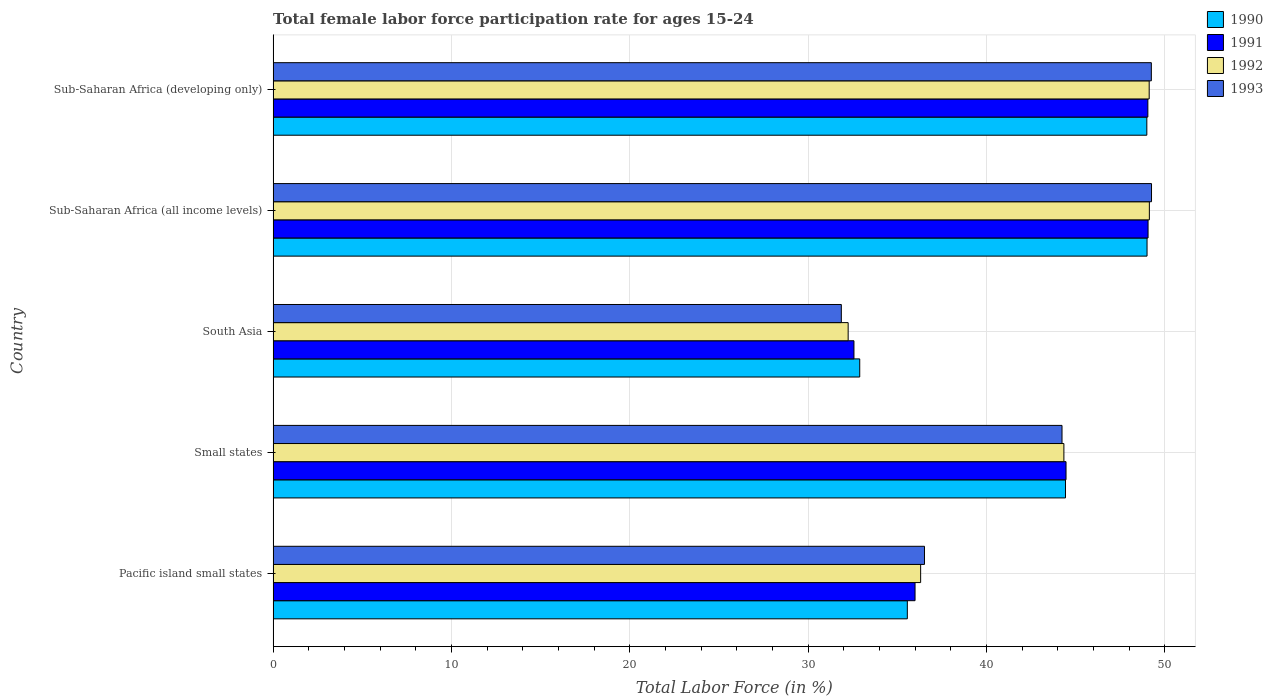How many groups of bars are there?
Offer a terse response. 5. Are the number of bars per tick equal to the number of legend labels?
Your response must be concise. Yes. How many bars are there on the 2nd tick from the top?
Your answer should be compact. 4. What is the label of the 5th group of bars from the top?
Provide a short and direct response. Pacific island small states. What is the female labor force participation rate in 1993 in Small states?
Offer a very short reply. 44.24. Across all countries, what is the maximum female labor force participation rate in 1990?
Make the answer very short. 49. Across all countries, what is the minimum female labor force participation rate in 1993?
Give a very brief answer. 31.86. In which country was the female labor force participation rate in 1991 maximum?
Provide a succinct answer. Sub-Saharan Africa (all income levels). In which country was the female labor force participation rate in 1992 minimum?
Your response must be concise. South Asia. What is the total female labor force participation rate in 1992 in the graph?
Offer a terse response. 211.15. What is the difference between the female labor force participation rate in 1992 in Small states and that in Sub-Saharan Africa (developing only)?
Your answer should be compact. -4.78. What is the difference between the female labor force participation rate in 1993 in South Asia and the female labor force participation rate in 1991 in Sub-Saharan Africa (developing only)?
Your response must be concise. -17.19. What is the average female labor force participation rate in 1991 per country?
Offer a terse response. 42.23. What is the difference between the female labor force participation rate in 1993 and female labor force participation rate in 1992 in Sub-Saharan Africa (all income levels)?
Provide a succinct answer. 0.12. In how many countries, is the female labor force participation rate in 1991 greater than 30 %?
Keep it short and to the point. 5. What is the ratio of the female labor force participation rate in 1991 in Sub-Saharan Africa (all income levels) to that in Sub-Saharan Africa (developing only)?
Offer a terse response. 1. Is the difference between the female labor force participation rate in 1993 in Small states and Sub-Saharan Africa (developing only) greater than the difference between the female labor force participation rate in 1992 in Small states and Sub-Saharan Africa (developing only)?
Your response must be concise. No. What is the difference between the highest and the second highest female labor force participation rate in 1991?
Your answer should be very brief. 0.01. What is the difference between the highest and the lowest female labor force participation rate in 1991?
Provide a short and direct response. 16.49. What does the 3rd bar from the bottom in Sub-Saharan Africa (developing only) represents?
Keep it short and to the point. 1992. How many bars are there?
Make the answer very short. 20. How many countries are there in the graph?
Provide a short and direct response. 5. What is the difference between two consecutive major ticks on the X-axis?
Offer a terse response. 10. Are the values on the major ticks of X-axis written in scientific E-notation?
Ensure brevity in your answer.  No. Does the graph contain any zero values?
Give a very brief answer. No. Does the graph contain grids?
Provide a succinct answer. Yes. How many legend labels are there?
Your answer should be very brief. 4. What is the title of the graph?
Keep it short and to the point. Total female labor force participation rate for ages 15-24. Does "1965" appear as one of the legend labels in the graph?
Give a very brief answer. No. What is the label or title of the X-axis?
Ensure brevity in your answer.  Total Labor Force (in %). What is the Total Labor Force (in %) of 1990 in Pacific island small states?
Your response must be concise. 35.56. What is the Total Labor Force (in %) of 1991 in Pacific island small states?
Ensure brevity in your answer.  35.99. What is the Total Labor Force (in %) in 1992 in Pacific island small states?
Provide a succinct answer. 36.31. What is the Total Labor Force (in %) of 1993 in Pacific island small states?
Provide a short and direct response. 36.52. What is the Total Labor Force (in %) of 1990 in Small states?
Provide a succinct answer. 44.43. What is the Total Labor Force (in %) in 1991 in Small states?
Your response must be concise. 44.46. What is the Total Labor Force (in %) of 1992 in Small states?
Keep it short and to the point. 44.34. What is the Total Labor Force (in %) in 1993 in Small states?
Make the answer very short. 44.24. What is the Total Labor Force (in %) in 1990 in South Asia?
Provide a short and direct response. 32.89. What is the Total Labor Force (in %) in 1991 in South Asia?
Provide a succinct answer. 32.57. What is the Total Labor Force (in %) of 1992 in South Asia?
Your answer should be compact. 32.24. What is the Total Labor Force (in %) of 1993 in South Asia?
Your answer should be very brief. 31.86. What is the Total Labor Force (in %) in 1990 in Sub-Saharan Africa (all income levels)?
Ensure brevity in your answer.  49. What is the Total Labor Force (in %) of 1991 in Sub-Saharan Africa (all income levels)?
Your answer should be very brief. 49.06. What is the Total Labor Force (in %) in 1992 in Sub-Saharan Africa (all income levels)?
Your response must be concise. 49.13. What is the Total Labor Force (in %) of 1993 in Sub-Saharan Africa (all income levels)?
Your answer should be compact. 49.25. What is the Total Labor Force (in %) in 1990 in Sub-Saharan Africa (developing only)?
Make the answer very short. 48.99. What is the Total Labor Force (in %) of 1991 in Sub-Saharan Africa (developing only)?
Your answer should be compact. 49.05. What is the Total Labor Force (in %) in 1992 in Sub-Saharan Africa (developing only)?
Ensure brevity in your answer.  49.12. What is the Total Labor Force (in %) in 1993 in Sub-Saharan Africa (developing only)?
Your answer should be very brief. 49.24. Across all countries, what is the maximum Total Labor Force (in %) in 1990?
Offer a very short reply. 49. Across all countries, what is the maximum Total Labor Force (in %) of 1991?
Provide a short and direct response. 49.06. Across all countries, what is the maximum Total Labor Force (in %) of 1992?
Your answer should be compact. 49.13. Across all countries, what is the maximum Total Labor Force (in %) in 1993?
Your answer should be compact. 49.25. Across all countries, what is the minimum Total Labor Force (in %) in 1990?
Offer a very short reply. 32.89. Across all countries, what is the minimum Total Labor Force (in %) of 1991?
Your answer should be very brief. 32.57. Across all countries, what is the minimum Total Labor Force (in %) in 1992?
Provide a short and direct response. 32.24. Across all countries, what is the minimum Total Labor Force (in %) of 1993?
Make the answer very short. 31.86. What is the total Total Labor Force (in %) of 1990 in the graph?
Give a very brief answer. 210.88. What is the total Total Labor Force (in %) in 1991 in the graph?
Keep it short and to the point. 211.13. What is the total Total Labor Force (in %) in 1992 in the graph?
Provide a short and direct response. 211.15. What is the total Total Labor Force (in %) in 1993 in the graph?
Your response must be concise. 211.12. What is the difference between the Total Labor Force (in %) in 1990 in Pacific island small states and that in Small states?
Offer a very short reply. -8.87. What is the difference between the Total Labor Force (in %) in 1991 in Pacific island small states and that in Small states?
Provide a succinct answer. -8.47. What is the difference between the Total Labor Force (in %) of 1992 in Pacific island small states and that in Small states?
Keep it short and to the point. -8.03. What is the difference between the Total Labor Force (in %) in 1993 in Pacific island small states and that in Small states?
Your answer should be very brief. -7.71. What is the difference between the Total Labor Force (in %) of 1990 in Pacific island small states and that in South Asia?
Your answer should be very brief. 2.67. What is the difference between the Total Labor Force (in %) in 1991 in Pacific island small states and that in South Asia?
Provide a succinct answer. 3.43. What is the difference between the Total Labor Force (in %) of 1992 in Pacific island small states and that in South Asia?
Give a very brief answer. 4.06. What is the difference between the Total Labor Force (in %) of 1993 in Pacific island small states and that in South Asia?
Offer a terse response. 4.66. What is the difference between the Total Labor Force (in %) of 1990 in Pacific island small states and that in Sub-Saharan Africa (all income levels)?
Your response must be concise. -13.44. What is the difference between the Total Labor Force (in %) in 1991 in Pacific island small states and that in Sub-Saharan Africa (all income levels)?
Offer a terse response. -13.07. What is the difference between the Total Labor Force (in %) in 1992 in Pacific island small states and that in Sub-Saharan Africa (all income levels)?
Ensure brevity in your answer.  -12.82. What is the difference between the Total Labor Force (in %) in 1993 in Pacific island small states and that in Sub-Saharan Africa (all income levels)?
Provide a short and direct response. -12.73. What is the difference between the Total Labor Force (in %) in 1990 in Pacific island small states and that in Sub-Saharan Africa (developing only)?
Your answer should be compact. -13.43. What is the difference between the Total Labor Force (in %) of 1991 in Pacific island small states and that in Sub-Saharan Africa (developing only)?
Your answer should be very brief. -13.05. What is the difference between the Total Labor Force (in %) in 1992 in Pacific island small states and that in Sub-Saharan Africa (developing only)?
Give a very brief answer. -12.81. What is the difference between the Total Labor Force (in %) in 1993 in Pacific island small states and that in Sub-Saharan Africa (developing only)?
Your response must be concise. -12.72. What is the difference between the Total Labor Force (in %) of 1990 in Small states and that in South Asia?
Make the answer very short. 11.54. What is the difference between the Total Labor Force (in %) in 1991 in Small states and that in South Asia?
Offer a terse response. 11.89. What is the difference between the Total Labor Force (in %) of 1992 in Small states and that in South Asia?
Give a very brief answer. 12.1. What is the difference between the Total Labor Force (in %) in 1993 in Small states and that in South Asia?
Your response must be concise. 12.37. What is the difference between the Total Labor Force (in %) in 1990 in Small states and that in Sub-Saharan Africa (all income levels)?
Offer a terse response. -4.57. What is the difference between the Total Labor Force (in %) in 1991 in Small states and that in Sub-Saharan Africa (all income levels)?
Give a very brief answer. -4.6. What is the difference between the Total Labor Force (in %) of 1992 in Small states and that in Sub-Saharan Africa (all income levels)?
Your answer should be compact. -4.79. What is the difference between the Total Labor Force (in %) in 1993 in Small states and that in Sub-Saharan Africa (all income levels)?
Your response must be concise. -5.02. What is the difference between the Total Labor Force (in %) in 1990 in Small states and that in Sub-Saharan Africa (developing only)?
Keep it short and to the point. -4.56. What is the difference between the Total Labor Force (in %) of 1991 in Small states and that in Sub-Saharan Africa (developing only)?
Keep it short and to the point. -4.59. What is the difference between the Total Labor Force (in %) in 1992 in Small states and that in Sub-Saharan Africa (developing only)?
Make the answer very short. -4.78. What is the difference between the Total Labor Force (in %) of 1993 in Small states and that in Sub-Saharan Africa (developing only)?
Make the answer very short. -5.01. What is the difference between the Total Labor Force (in %) of 1990 in South Asia and that in Sub-Saharan Africa (all income levels)?
Offer a terse response. -16.11. What is the difference between the Total Labor Force (in %) of 1991 in South Asia and that in Sub-Saharan Africa (all income levels)?
Offer a very short reply. -16.49. What is the difference between the Total Labor Force (in %) of 1992 in South Asia and that in Sub-Saharan Africa (all income levels)?
Make the answer very short. -16.89. What is the difference between the Total Labor Force (in %) in 1993 in South Asia and that in Sub-Saharan Africa (all income levels)?
Keep it short and to the point. -17.39. What is the difference between the Total Labor Force (in %) in 1990 in South Asia and that in Sub-Saharan Africa (developing only)?
Offer a terse response. -16.1. What is the difference between the Total Labor Force (in %) in 1991 in South Asia and that in Sub-Saharan Africa (developing only)?
Ensure brevity in your answer.  -16.48. What is the difference between the Total Labor Force (in %) in 1992 in South Asia and that in Sub-Saharan Africa (developing only)?
Give a very brief answer. -16.88. What is the difference between the Total Labor Force (in %) in 1993 in South Asia and that in Sub-Saharan Africa (developing only)?
Ensure brevity in your answer.  -17.38. What is the difference between the Total Labor Force (in %) in 1990 in Sub-Saharan Africa (all income levels) and that in Sub-Saharan Africa (developing only)?
Provide a succinct answer. 0.01. What is the difference between the Total Labor Force (in %) of 1991 in Sub-Saharan Africa (all income levels) and that in Sub-Saharan Africa (developing only)?
Keep it short and to the point. 0.01. What is the difference between the Total Labor Force (in %) in 1992 in Sub-Saharan Africa (all income levels) and that in Sub-Saharan Africa (developing only)?
Your response must be concise. 0.01. What is the difference between the Total Labor Force (in %) in 1993 in Sub-Saharan Africa (all income levels) and that in Sub-Saharan Africa (developing only)?
Provide a succinct answer. 0.01. What is the difference between the Total Labor Force (in %) of 1990 in Pacific island small states and the Total Labor Force (in %) of 1991 in Small states?
Your answer should be compact. -8.9. What is the difference between the Total Labor Force (in %) of 1990 in Pacific island small states and the Total Labor Force (in %) of 1992 in Small states?
Your answer should be compact. -8.78. What is the difference between the Total Labor Force (in %) of 1990 in Pacific island small states and the Total Labor Force (in %) of 1993 in Small states?
Give a very brief answer. -8.67. What is the difference between the Total Labor Force (in %) in 1991 in Pacific island small states and the Total Labor Force (in %) in 1992 in Small states?
Ensure brevity in your answer.  -8.35. What is the difference between the Total Labor Force (in %) of 1991 in Pacific island small states and the Total Labor Force (in %) of 1993 in Small states?
Make the answer very short. -8.24. What is the difference between the Total Labor Force (in %) in 1992 in Pacific island small states and the Total Labor Force (in %) in 1993 in Small states?
Provide a succinct answer. -7.93. What is the difference between the Total Labor Force (in %) in 1990 in Pacific island small states and the Total Labor Force (in %) in 1991 in South Asia?
Give a very brief answer. 2.99. What is the difference between the Total Labor Force (in %) of 1990 in Pacific island small states and the Total Labor Force (in %) of 1992 in South Asia?
Keep it short and to the point. 3.32. What is the difference between the Total Labor Force (in %) of 1990 in Pacific island small states and the Total Labor Force (in %) of 1993 in South Asia?
Ensure brevity in your answer.  3.7. What is the difference between the Total Labor Force (in %) of 1991 in Pacific island small states and the Total Labor Force (in %) of 1992 in South Asia?
Your response must be concise. 3.75. What is the difference between the Total Labor Force (in %) in 1991 in Pacific island small states and the Total Labor Force (in %) in 1993 in South Asia?
Provide a succinct answer. 4.13. What is the difference between the Total Labor Force (in %) in 1992 in Pacific island small states and the Total Labor Force (in %) in 1993 in South Asia?
Provide a short and direct response. 4.45. What is the difference between the Total Labor Force (in %) of 1990 in Pacific island small states and the Total Labor Force (in %) of 1991 in Sub-Saharan Africa (all income levels)?
Provide a short and direct response. -13.5. What is the difference between the Total Labor Force (in %) of 1990 in Pacific island small states and the Total Labor Force (in %) of 1992 in Sub-Saharan Africa (all income levels)?
Keep it short and to the point. -13.57. What is the difference between the Total Labor Force (in %) of 1990 in Pacific island small states and the Total Labor Force (in %) of 1993 in Sub-Saharan Africa (all income levels)?
Your response must be concise. -13.69. What is the difference between the Total Labor Force (in %) of 1991 in Pacific island small states and the Total Labor Force (in %) of 1992 in Sub-Saharan Africa (all income levels)?
Your answer should be compact. -13.14. What is the difference between the Total Labor Force (in %) of 1991 in Pacific island small states and the Total Labor Force (in %) of 1993 in Sub-Saharan Africa (all income levels)?
Provide a short and direct response. -13.26. What is the difference between the Total Labor Force (in %) in 1992 in Pacific island small states and the Total Labor Force (in %) in 1993 in Sub-Saharan Africa (all income levels)?
Keep it short and to the point. -12.95. What is the difference between the Total Labor Force (in %) of 1990 in Pacific island small states and the Total Labor Force (in %) of 1991 in Sub-Saharan Africa (developing only)?
Your answer should be very brief. -13.49. What is the difference between the Total Labor Force (in %) in 1990 in Pacific island small states and the Total Labor Force (in %) in 1992 in Sub-Saharan Africa (developing only)?
Provide a short and direct response. -13.56. What is the difference between the Total Labor Force (in %) of 1990 in Pacific island small states and the Total Labor Force (in %) of 1993 in Sub-Saharan Africa (developing only)?
Provide a short and direct response. -13.68. What is the difference between the Total Labor Force (in %) in 1991 in Pacific island small states and the Total Labor Force (in %) in 1992 in Sub-Saharan Africa (developing only)?
Offer a very short reply. -13.13. What is the difference between the Total Labor Force (in %) of 1991 in Pacific island small states and the Total Labor Force (in %) of 1993 in Sub-Saharan Africa (developing only)?
Your response must be concise. -13.25. What is the difference between the Total Labor Force (in %) in 1992 in Pacific island small states and the Total Labor Force (in %) in 1993 in Sub-Saharan Africa (developing only)?
Ensure brevity in your answer.  -12.94. What is the difference between the Total Labor Force (in %) of 1990 in Small states and the Total Labor Force (in %) of 1991 in South Asia?
Give a very brief answer. 11.86. What is the difference between the Total Labor Force (in %) in 1990 in Small states and the Total Labor Force (in %) in 1992 in South Asia?
Give a very brief answer. 12.19. What is the difference between the Total Labor Force (in %) of 1990 in Small states and the Total Labor Force (in %) of 1993 in South Asia?
Offer a very short reply. 12.57. What is the difference between the Total Labor Force (in %) in 1991 in Small states and the Total Labor Force (in %) in 1992 in South Asia?
Your answer should be very brief. 12.22. What is the difference between the Total Labor Force (in %) in 1991 in Small states and the Total Labor Force (in %) in 1993 in South Asia?
Provide a short and direct response. 12.6. What is the difference between the Total Labor Force (in %) in 1992 in Small states and the Total Labor Force (in %) in 1993 in South Asia?
Offer a terse response. 12.48. What is the difference between the Total Labor Force (in %) of 1990 in Small states and the Total Labor Force (in %) of 1991 in Sub-Saharan Africa (all income levels)?
Provide a succinct answer. -4.63. What is the difference between the Total Labor Force (in %) of 1990 in Small states and the Total Labor Force (in %) of 1992 in Sub-Saharan Africa (all income levels)?
Offer a very short reply. -4.7. What is the difference between the Total Labor Force (in %) of 1990 in Small states and the Total Labor Force (in %) of 1993 in Sub-Saharan Africa (all income levels)?
Your answer should be compact. -4.82. What is the difference between the Total Labor Force (in %) in 1991 in Small states and the Total Labor Force (in %) in 1992 in Sub-Saharan Africa (all income levels)?
Keep it short and to the point. -4.67. What is the difference between the Total Labor Force (in %) of 1991 in Small states and the Total Labor Force (in %) of 1993 in Sub-Saharan Africa (all income levels)?
Your answer should be compact. -4.79. What is the difference between the Total Labor Force (in %) of 1992 in Small states and the Total Labor Force (in %) of 1993 in Sub-Saharan Africa (all income levels)?
Provide a succinct answer. -4.91. What is the difference between the Total Labor Force (in %) of 1990 in Small states and the Total Labor Force (in %) of 1991 in Sub-Saharan Africa (developing only)?
Offer a terse response. -4.62. What is the difference between the Total Labor Force (in %) in 1990 in Small states and the Total Labor Force (in %) in 1992 in Sub-Saharan Africa (developing only)?
Your answer should be very brief. -4.69. What is the difference between the Total Labor Force (in %) in 1990 in Small states and the Total Labor Force (in %) in 1993 in Sub-Saharan Africa (developing only)?
Provide a succinct answer. -4.81. What is the difference between the Total Labor Force (in %) of 1991 in Small states and the Total Labor Force (in %) of 1992 in Sub-Saharan Africa (developing only)?
Provide a succinct answer. -4.66. What is the difference between the Total Labor Force (in %) of 1991 in Small states and the Total Labor Force (in %) of 1993 in Sub-Saharan Africa (developing only)?
Offer a very short reply. -4.78. What is the difference between the Total Labor Force (in %) of 1992 in Small states and the Total Labor Force (in %) of 1993 in Sub-Saharan Africa (developing only)?
Keep it short and to the point. -4.9. What is the difference between the Total Labor Force (in %) of 1990 in South Asia and the Total Labor Force (in %) of 1991 in Sub-Saharan Africa (all income levels)?
Your answer should be very brief. -16.17. What is the difference between the Total Labor Force (in %) in 1990 in South Asia and the Total Labor Force (in %) in 1992 in Sub-Saharan Africa (all income levels)?
Keep it short and to the point. -16.24. What is the difference between the Total Labor Force (in %) in 1990 in South Asia and the Total Labor Force (in %) in 1993 in Sub-Saharan Africa (all income levels)?
Offer a terse response. -16.36. What is the difference between the Total Labor Force (in %) of 1991 in South Asia and the Total Labor Force (in %) of 1992 in Sub-Saharan Africa (all income levels)?
Offer a terse response. -16.56. What is the difference between the Total Labor Force (in %) of 1991 in South Asia and the Total Labor Force (in %) of 1993 in Sub-Saharan Africa (all income levels)?
Offer a very short reply. -16.68. What is the difference between the Total Labor Force (in %) of 1992 in South Asia and the Total Labor Force (in %) of 1993 in Sub-Saharan Africa (all income levels)?
Offer a very short reply. -17.01. What is the difference between the Total Labor Force (in %) in 1990 in South Asia and the Total Labor Force (in %) in 1991 in Sub-Saharan Africa (developing only)?
Keep it short and to the point. -16.16. What is the difference between the Total Labor Force (in %) in 1990 in South Asia and the Total Labor Force (in %) in 1992 in Sub-Saharan Africa (developing only)?
Keep it short and to the point. -16.23. What is the difference between the Total Labor Force (in %) of 1990 in South Asia and the Total Labor Force (in %) of 1993 in Sub-Saharan Africa (developing only)?
Provide a succinct answer. -16.35. What is the difference between the Total Labor Force (in %) of 1991 in South Asia and the Total Labor Force (in %) of 1992 in Sub-Saharan Africa (developing only)?
Offer a very short reply. -16.55. What is the difference between the Total Labor Force (in %) of 1991 in South Asia and the Total Labor Force (in %) of 1993 in Sub-Saharan Africa (developing only)?
Your answer should be compact. -16.68. What is the difference between the Total Labor Force (in %) of 1992 in South Asia and the Total Labor Force (in %) of 1993 in Sub-Saharan Africa (developing only)?
Ensure brevity in your answer.  -17. What is the difference between the Total Labor Force (in %) of 1990 in Sub-Saharan Africa (all income levels) and the Total Labor Force (in %) of 1991 in Sub-Saharan Africa (developing only)?
Provide a short and direct response. -0.05. What is the difference between the Total Labor Force (in %) of 1990 in Sub-Saharan Africa (all income levels) and the Total Labor Force (in %) of 1992 in Sub-Saharan Africa (developing only)?
Your response must be concise. -0.12. What is the difference between the Total Labor Force (in %) in 1990 in Sub-Saharan Africa (all income levels) and the Total Labor Force (in %) in 1993 in Sub-Saharan Africa (developing only)?
Give a very brief answer. -0.24. What is the difference between the Total Labor Force (in %) in 1991 in Sub-Saharan Africa (all income levels) and the Total Labor Force (in %) in 1992 in Sub-Saharan Africa (developing only)?
Your response must be concise. -0.06. What is the difference between the Total Labor Force (in %) of 1991 in Sub-Saharan Africa (all income levels) and the Total Labor Force (in %) of 1993 in Sub-Saharan Africa (developing only)?
Offer a terse response. -0.18. What is the difference between the Total Labor Force (in %) in 1992 in Sub-Saharan Africa (all income levels) and the Total Labor Force (in %) in 1993 in Sub-Saharan Africa (developing only)?
Ensure brevity in your answer.  -0.11. What is the average Total Labor Force (in %) of 1990 per country?
Provide a succinct answer. 42.18. What is the average Total Labor Force (in %) in 1991 per country?
Provide a succinct answer. 42.23. What is the average Total Labor Force (in %) of 1992 per country?
Provide a short and direct response. 42.23. What is the average Total Labor Force (in %) in 1993 per country?
Provide a succinct answer. 42.22. What is the difference between the Total Labor Force (in %) in 1990 and Total Labor Force (in %) in 1991 in Pacific island small states?
Offer a very short reply. -0.43. What is the difference between the Total Labor Force (in %) of 1990 and Total Labor Force (in %) of 1992 in Pacific island small states?
Provide a succinct answer. -0.75. What is the difference between the Total Labor Force (in %) of 1990 and Total Labor Force (in %) of 1993 in Pacific island small states?
Your response must be concise. -0.96. What is the difference between the Total Labor Force (in %) of 1991 and Total Labor Force (in %) of 1992 in Pacific island small states?
Your answer should be compact. -0.31. What is the difference between the Total Labor Force (in %) of 1991 and Total Labor Force (in %) of 1993 in Pacific island small states?
Make the answer very short. -0.53. What is the difference between the Total Labor Force (in %) of 1992 and Total Labor Force (in %) of 1993 in Pacific island small states?
Offer a very short reply. -0.22. What is the difference between the Total Labor Force (in %) in 1990 and Total Labor Force (in %) in 1991 in Small states?
Make the answer very short. -0.03. What is the difference between the Total Labor Force (in %) in 1990 and Total Labor Force (in %) in 1992 in Small states?
Your answer should be very brief. 0.09. What is the difference between the Total Labor Force (in %) in 1990 and Total Labor Force (in %) in 1993 in Small states?
Give a very brief answer. 0.19. What is the difference between the Total Labor Force (in %) in 1991 and Total Labor Force (in %) in 1992 in Small states?
Offer a terse response. 0.12. What is the difference between the Total Labor Force (in %) in 1991 and Total Labor Force (in %) in 1993 in Small states?
Your answer should be very brief. 0.22. What is the difference between the Total Labor Force (in %) of 1992 and Total Labor Force (in %) of 1993 in Small states?
Provide a short and direct response. 0.1. What is the difference between the Total Labor Force (in %) of 1990 and Total Labor Force (in %) of 1991 in South Asia?
Give a very brief answer. 0.32. What is the difference between the Total Labor Force (in %) in 1990 and Total Labor Force (in %) in 1992 in South Asia?
Offer a terse response. 0.65. What is the difference between the Total Labor Force (in %) of 1990 and Total Labor Force (in %) of 1993 in South Asia?
Provide a succinct answer. 1.03. What is the difference between the Total Labor Force (in %) in 1991 and Total Labor Force (in %) in 1992 in South Asia?
Make the answer very short. 0.32. What is the difference between the Total Labor Force (in %) of 1991 and Total Labor Force (in %) of 1993 in South Asia?
Make the answer very short. 0.71. What is the difference between the Total Labor Force (in %) of 1992 and Total Labor Force (in %) of 1993 in South Asia?
Your answer should be very brief. 0.38. What is the difference between the Total Labor Force (in %) in 1990 and Total Labor Force (in %) in 1991 in Sub-Saharan Africa (all income levels)?
Provide a succinct answer. -0.06. What is the difference between the Total Labor Force (in %) in 1990 and Total Labor Force (in %) in 1992 in Sub-Saharan Africa (all income levels)?
Offer a very short reply. -0.13. What is the difference between the Total Labor Force (in %) in 1990 and Total Labor Force (in %) in 1993 in Sub-Saharan Africa (all income levels)?
Provide a short and direct response. -0.25. What is the difference between the Total Labor Force (in %) in 1991 and Total Labor Force (in %) in 1992 in Sub-Saharan Africa (all income levels)?
Keep it short and to the point. -0.07. What is the difference between the Total Labor Force (in %) of 1991 and Total Labor Force (in %) of 1993 in Sub-Saharan Africa (all income levels)?
Give a very brief answer. -0.19. What is the difference between the Total Labor Force (in %) of 1992 and Total Labor Force (in %) of 1993 in Sub-Saharan Africa (all income levels)?
Provide a short and direct response. -0.12. What is the difference between the Total Labor Force (in %) in 1990 and Total Labor Force (in %) in 1991 in Sub-Saharan Africa (developing only)?
Make the answer very short. -0.06. What is the difference between the Total Labor Force (in %) of 1990 and Total Labor Force (in %) of 1992 in Sub-Saharan Africa (developing only)?
Your answer should be very brief. -0.13. What is the difference between the Total Labor Force (in %) in 1990 and Total Labor Force (in %) in 1993 in Sub-Saharan Africa (developing only)?
Offer a terse response. -0.25. What is the difference between the Total Labor Force (in %) in 1991 and Total Labor Force (in %) in 1992 in Sub-Saharan Africa (developing only)?
Provide a short and direct response. -0.07. What is the difference between the Total Labor Force (in %) in 1991 and Total Labor Force (in %) in 1993 in Sub-Saharan Africa (developing only)?
Provide a short and direct response. -0.2. What is the difference between the Total Labor Force (in %) of 1992 and Total Labor Force (in %) of 1993 in Sub-Saharan Africa (developing only)?
Give a very brief answer. -0.12. What is the ratio of the Total Labor Force (in %) of 1990 in Pacific island small states to that in Small states?
Provide a succinct answer. 0.8. What is the ratio of the Total Labor Force (in %) of 1991 in Pacific island small states to that in Small states?
Your answer should be very brief. 0.81. What is the ratio of the Total Labor Force (in %) in 1992 in Pacific island small states to that in Small states?
Offer a terse response. 0.82. What is the ratio of the Total Labor Force (in %) in 1993 in Pacific island small states to that in Small states?
Provide a succinct answer. 0.83. What is the ratio of the Total Labor Force (in %) of 1990 in Pacific island small states to that in South Asia?
Your response must be concise. 1.08. What is the ratio of the Total Labor Force (in %) of 1991 in Pacific island small states to that in South Asia?
Provide a short and direct response. 1.11. What is the ratio of the Total Labor Force (in %) in 1992 in Pacific island small states to that in South Asia?
Offer a terse response. 1.13. What is the ratio of the Total Labor Force (in %) in 1993 in Pacific island small states to that in South Asia?
Provide a short and direct response. 1.15. What is the ratio of the Total Labor Force (in %) of 1990 in Pacific island small states to that in Sub-Saharan Africa (all income levels)?
Provide a short and direct response. 0.73. What is the ratio of the Total Labor Force (in %) of 1991 in Pacific island small states to that in Sub-Saharan Africa (all income levels)?
Offer a terse response. 0.73. What is the ratio of the Total Labor Force (in %) in 1992 in Pacific island small states to that in Sub-Saharan Africa (all income levels)?
Provide a short and direct response. 0.74. What is the ratio of the Total Labor Force (in %) in 1993 in Pacific island small states to that in Sub-Saharan Africa (all income levels)?
Your answer should be very brief. 0.74. What is the ratio of the Total Labor Force (in %) in 1990 in Pacific island small states to that in Sub-Saharan Africa (developing only)?
Provide a short and direct response. 0.73. What is the ratio of the Total Labor Force (in %) of 1991 in Pacific island small states to that in Sub-Saharan Africa (developing only)?
Give a very brief answer. 0.73. What is the ratio of the Total Labor Force (in %) of 1992 in Pacific island small states to that in Sub-Saharan Africa (developing only)?
Your response must be concise. 0.74. What is the ratio of the Total Labor Force (in %) of 1993 in Pacific island small states to that in Sub-Saharan Africa (developing only)?
Ensure brevity in your answer.  0.74. What is the ratio of the Total Labor Force (in %) in 1990 in Small states to that in South Asia?
Your response must be concise. 1.35. What is the ratio of the Total Labor Force (in %) in 1991 in Small states to that in South Asia?
Your answer should be compact. 1.37. What is the ratio of the Total Labor Force (in %) in 1992 in Small states to that in South Asia?
Give a very brief answer. 1.38. What is the ratio of the Total Labor Force (in %) of 1993 in Small states to that in South Asia?
Your answer should be compact. 1.39. What is the ratio of the Total Labor Force (in %) in 1990 in Small states to that in Sub-Saharan Africa (all income levels)?
Your response must be concise. 0.91. What is the ratio of the Total Labor Force (in %) in 1991 in Small states to that in Sub-Saharan Africa (all income levels)?
Keep it short and to the point. 0.91. What is the ratio of the Total Labor Force (in %) of 1992 in Small states to that in Sub-Saharan Africa (all income levels)?
Provide a succinct answer. 0.9. What is the ratio of the Total Labor Force (in %) of 1993 in Small states to that in Sub-Saharan Africa (all income levels)?
Keep it short and to the point. 0.9. What is the ratio of the Total Labor Force (in %) of 1990 in Small states to that in Sub-Saharan Africa (developing only)?
Ensure brevity in your answer.  0.91. What is the ratio of the Total Labor Force (in %) of 1991 in Small states to that in Sub-Saharan Africa (developing only)?
Your answer should be very brief. 0.91. What is the ratio of the Total Labor Force (in %) in 1992 in Small states to that in Sub-Saharan Africa (developing only)?
Make the answer very short. 0.9. What is the ratio of the Total Labor Force (in %) in 1993 in Small states to that in Sub-Saharan Africa (developing only)?
Your answer should be very brief. 0.9. What is the ratio of the Total Labor Force (in %) in 1990 in South Asia to that in Sub-Saharan Africa (all income levels)?
Ensure brevity in your answer.  0.67. What is the ratio of the Total Labor Force (in %) of 1991 in South Asia to that in Sub-Saharan Africa (all income levels)?
Keep it short and to the point. 0.66. What is the ratio of the Total Labor Force (in %) of 1992 in South Asia to that in Sub-Saharan Africa (all income levels)?
Give a very brief answer. 0.66. What is the ratio of the Total Labor Force (in %) in 1993 in South Asia to that in Sub-Saharan Africa (all income levels)?
Offer a very short reply. 0.65. What is the ratio of the Total Labor Force (in %) in 1990 in South Asia to that in Sub-Saharan Africa (developing only)?
Your answer should be compact. 0.67. What is the ratio of the Total Labor Force (in %) in 1991 in South Asia to that in Sub-Saharan Africa (developing only)?
Give a very brief answer. 0.66. What is the ratio of the Total Labor Force (in %) in 1992 in South Asia to that in Sub-Saharan Africa (developing only)?
Your response must be concise. 0.66. What is the ratio of the Total Labor Force (in %) of 1993 in South Asia to that in Sub-Saharan Africa (developing only)?
Ensure brevity in your answer.  0.65. What is the ratio of the Total Labor Force (in %) of 1993 in Sub-Saharan Africa (all income levels) to that in Sub-Saharan Africa (developing only)?
Your answer should be compact. 1. What is the difference between the highest and the second highest Total Labor Force (in %) in 1990?
Your answer should be compact. 0.01. What is the difference between the highest and the second highest Total Labor Force (in %) in 1991?
Provide a short and direct response. 0.01. What is the difference between the highest and the second highest Total Labor Force (in %) in 1992?
Keep it short and to the point. 0.01. What is the difference between the highest and the second highest Total Labor Force (in %) in 1993?
Give a very brief answer. 0.01. What is the difference between the highest and the lowest Total Labor Force (in %) in 1990?
Offer a terse response. 16.11. What is the difference between the highest and the lowest Total Labor Force (in %) of 1991?
Offer a very short reply. 16.49. What is the difference between the highest and the lowest Total Labor Force (in %) of 1992?
Provide a succinct answer. 16.89. What is the difference between the highest and the lowest Total Labor Force (in %) in 1993?
Keep it short and to the point. 17.39. 